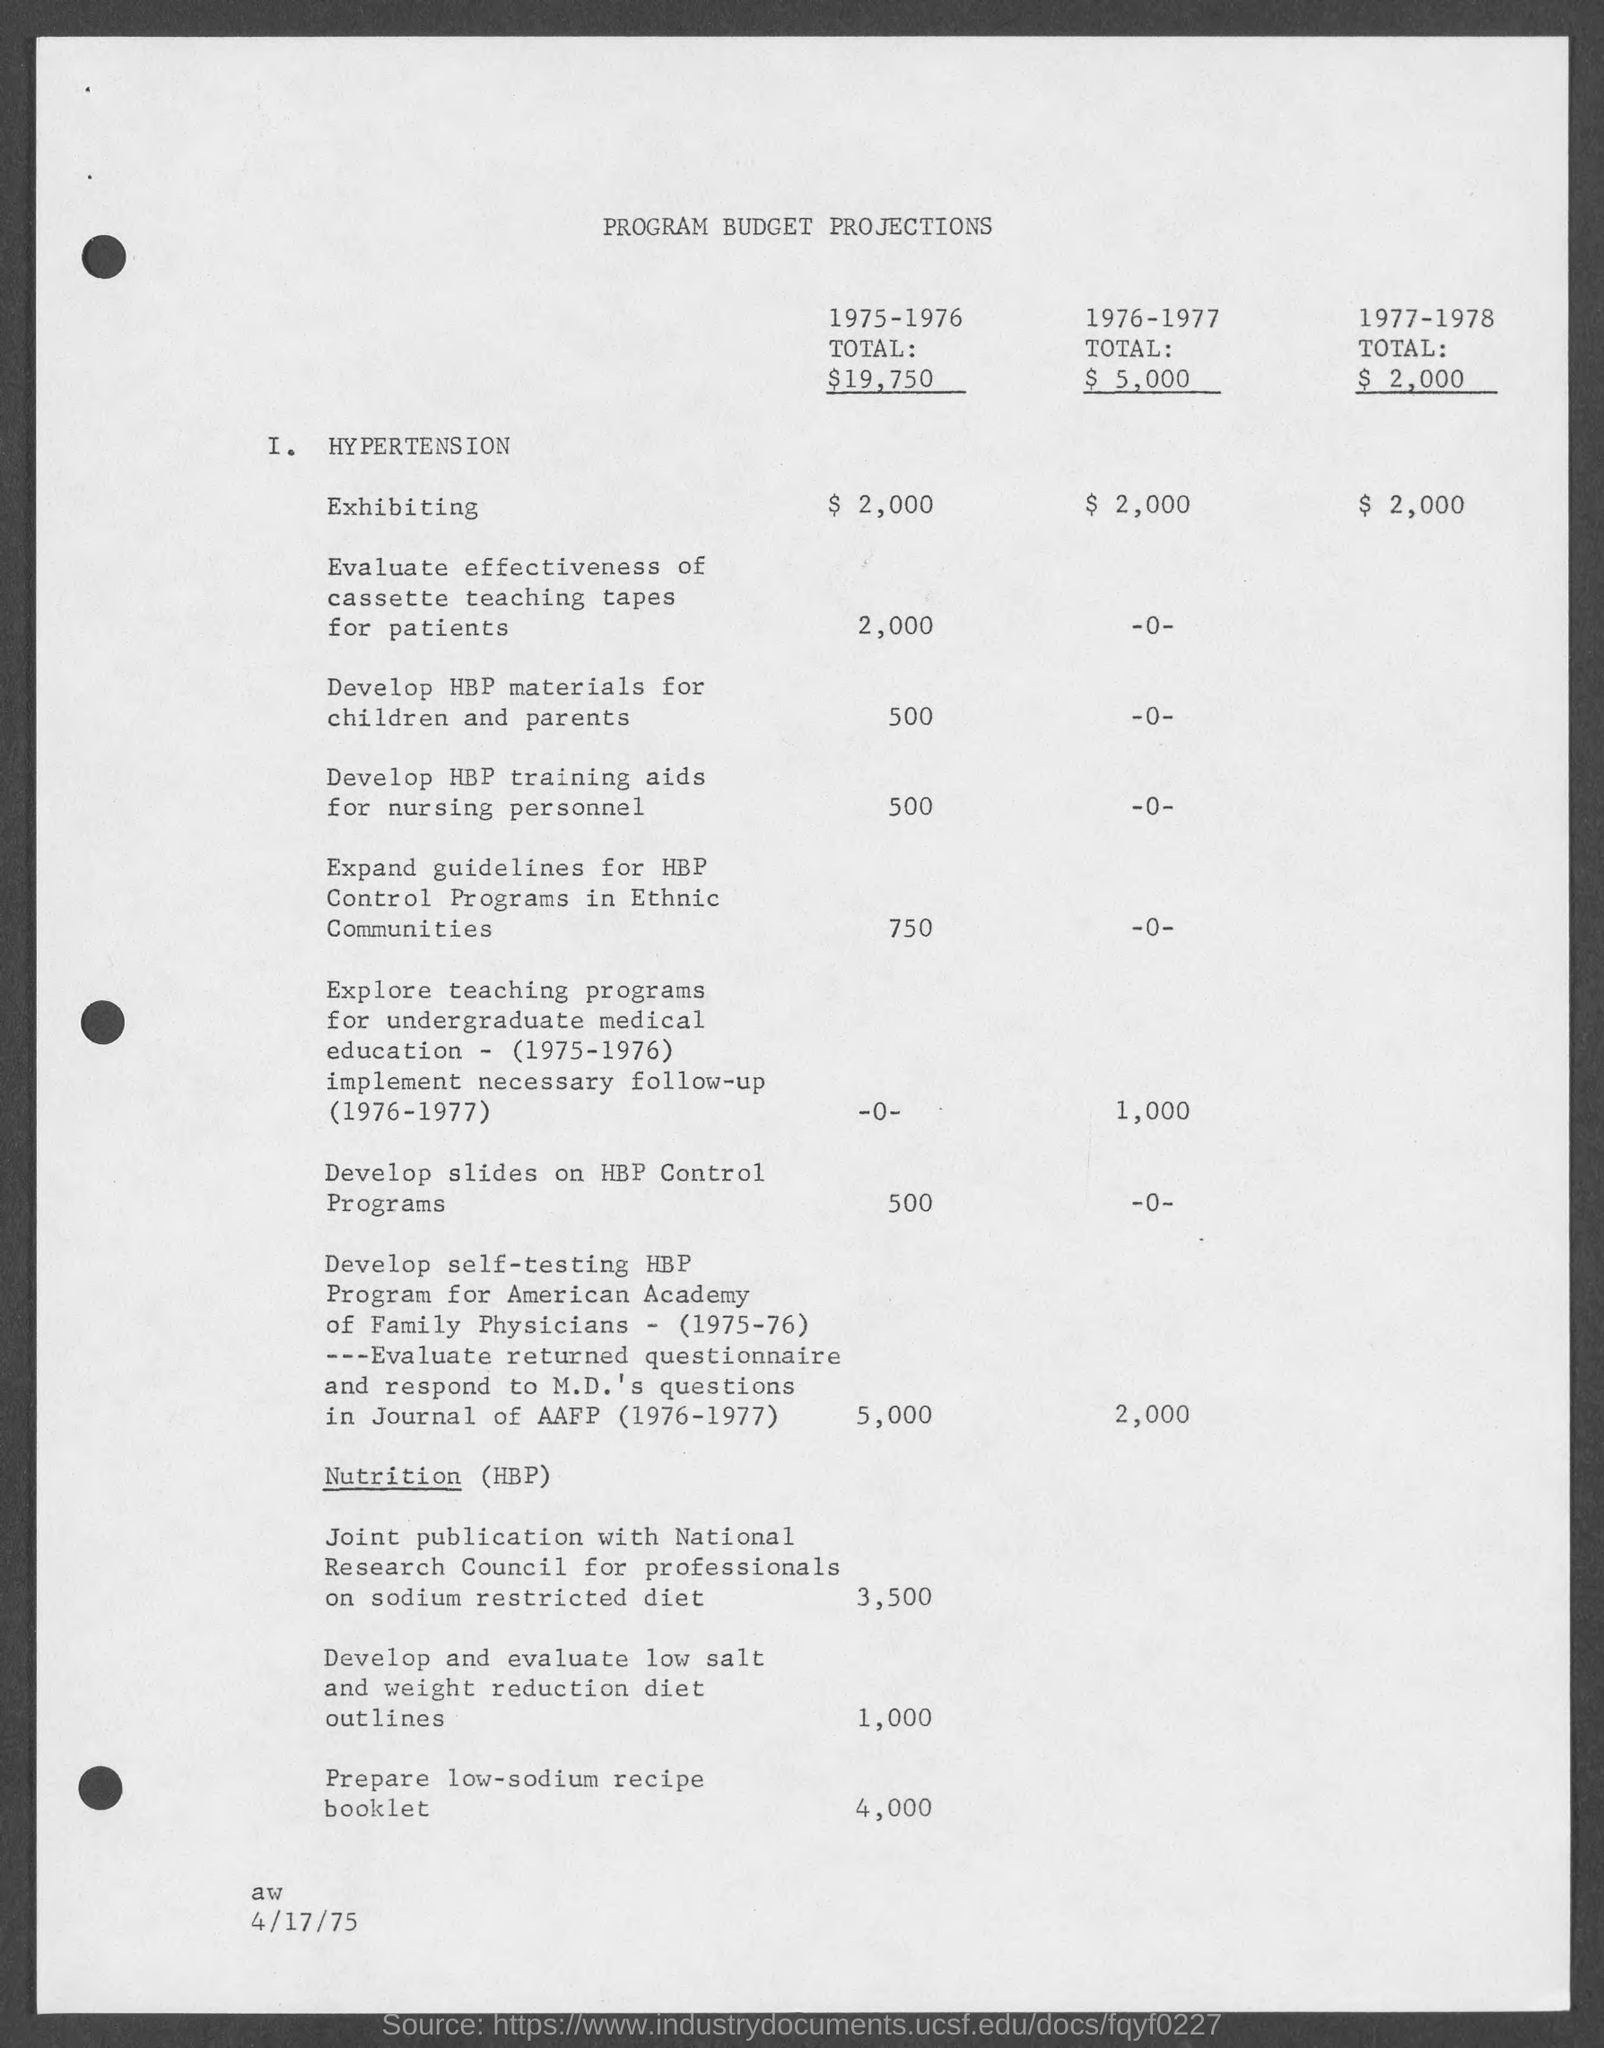Draw attention to some important aspects in this diagram. The date at the bottom of the page is April 17th, 1975. In 1977-1978, the total was $2000. In 1975-1976, the total was $19,750. In 1976-1977, the total was $5,000. The title of the page is "Program Budget Projections". 